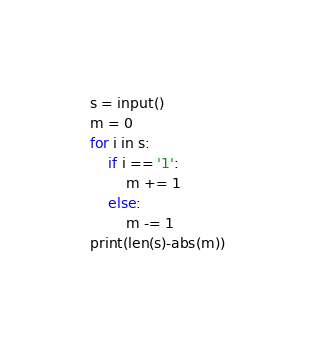<code> <loc_0><loc_0><loc_500><loc_500><_Python_>s = input()
m = 0
for i in s:
    if i == '1':
        m += 1
    else:
        m -= 1
print(len(s)-abs(m))</code> 